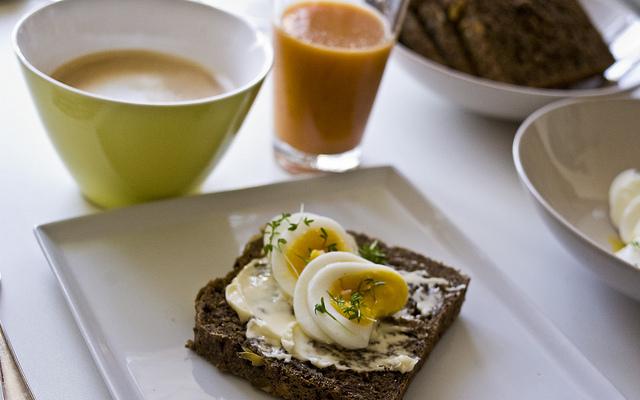What color is the plate?
Write a very short answer. White. What color plate is being used?
Quick response, please. White. What type of bread is on the plate?
Keep it brief. Rye. 